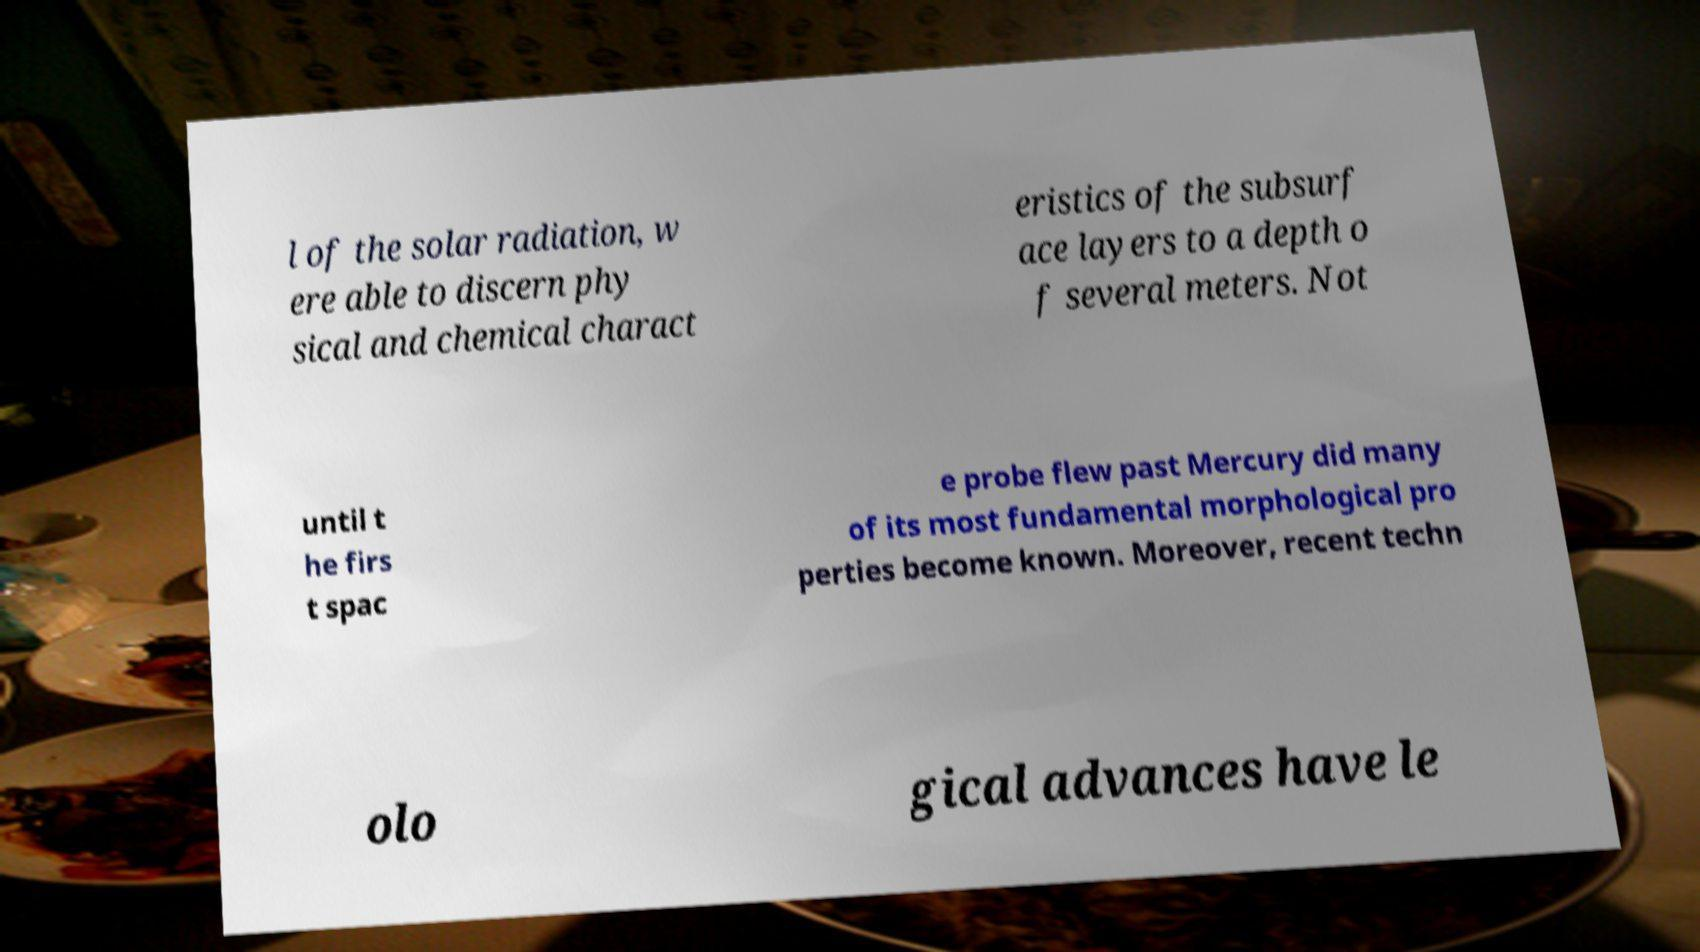Please read and relay the text visible in this image. What does it say? l of the solar radiation, w ere able to discern phy sical and chemical charact eristics of the subsurf ace layers to a depth o f several meters. Not until t he firs t spac e probe flew past Mercury did many of its most fundamental morphological pro perties become known. Moreover, recent techn olo gical advances have le 